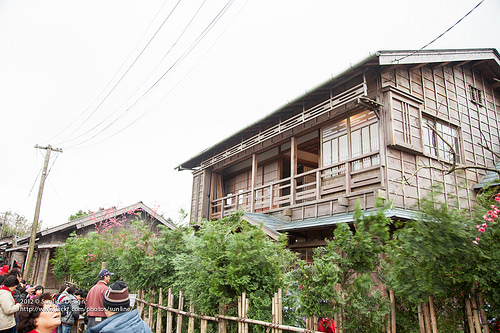<image>
Can you confirm if the sky is behind the tree? Yes. From this viewpoint, the sky is positioned behind the tree, with the tree partially or fully occluding the sky. 